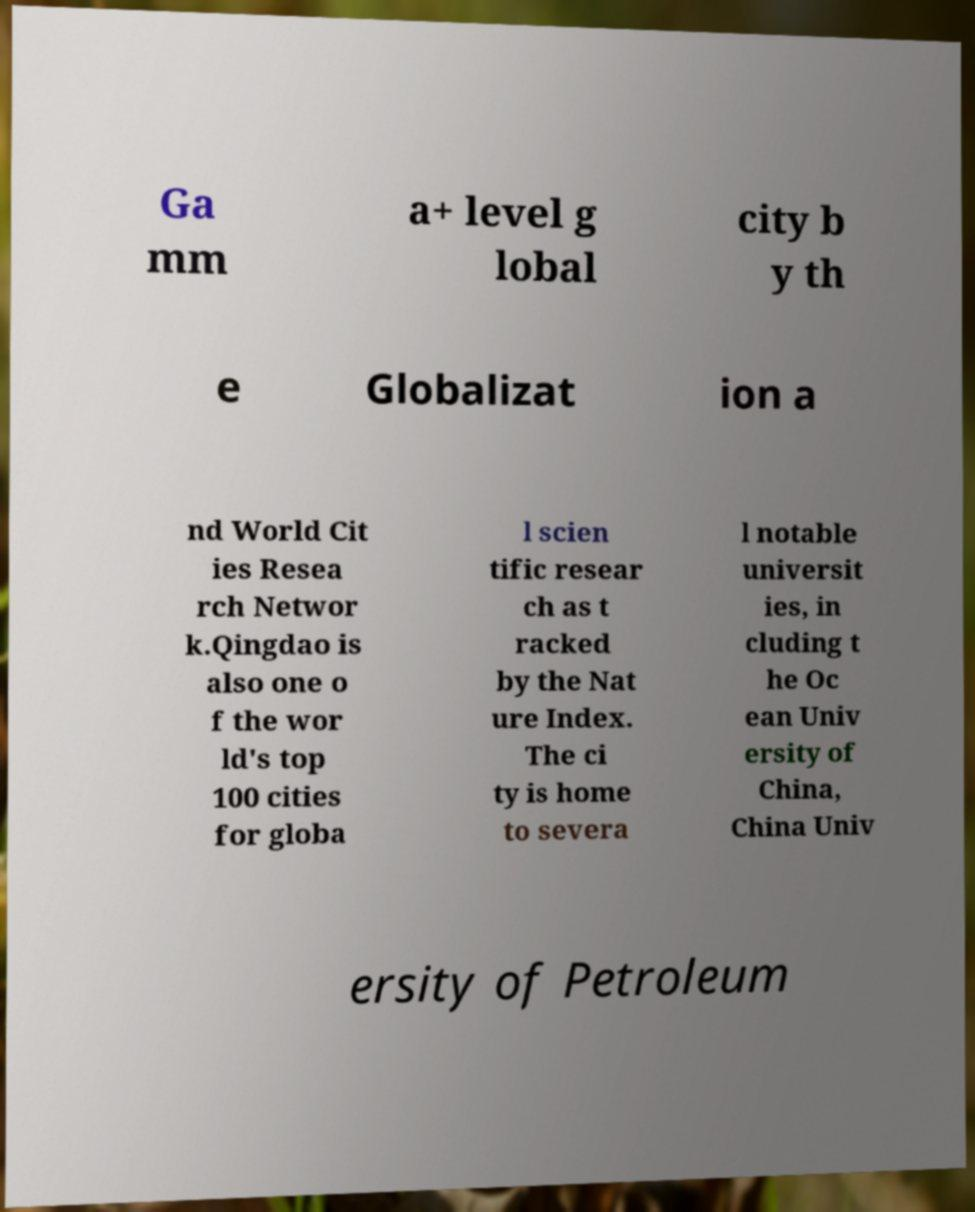Can you read and provide the text displayed in the image?This photo seems to have some interesting text. Can you extract and type it out for me? Ga mm a+ level g lobal city b y th e Globalizat ion a nd World Cit ies Resea rch Networ k.Qingdao is also one o f the wor ld's top 100 cities for globa l scien tific resear ch as t racked by the Nat ure Index. The ci ty is home to severa l notable universit ies, in cluding t he Oc ean Univ ersity of China, China Univ ersity of Petroleum 